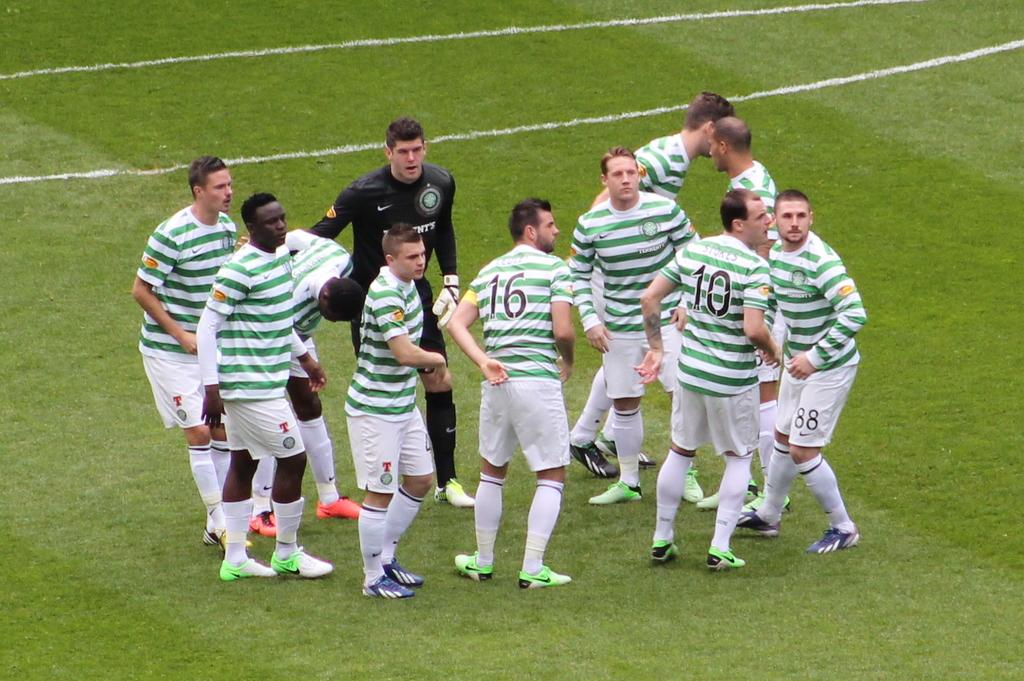<image>
Share a concise interpretation of the image provided. green and white stripped jerseys included number 10 and 16 players on the field 